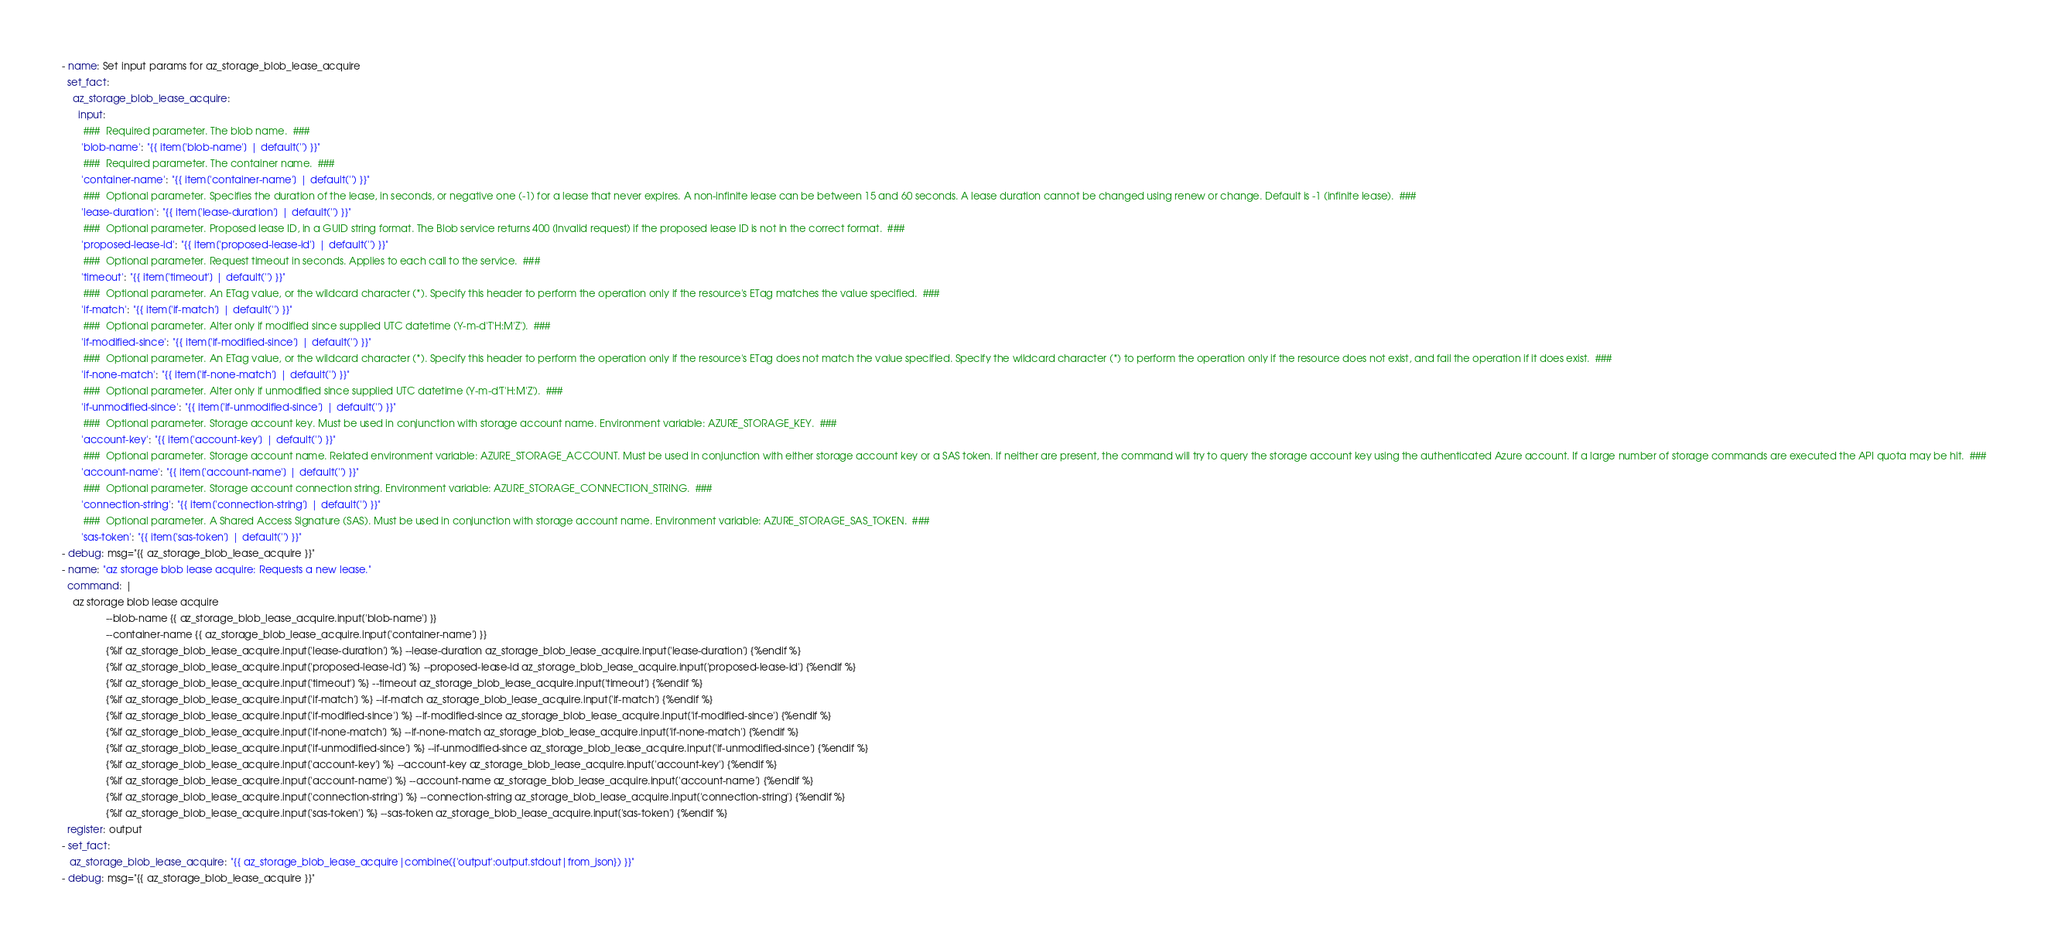Convert code to text. <code><loc_0><loc_0><loc_500><loc_500><_YAML_>

 - name: Set input params for az_storage_blob_lease_acquire
   set_fact: 
     az_storage_blob_lease_acquire:
       input: 
         ###  Required parameter. The blob name.  ### 
        'blob-name': "{{ item['blob-name'] | default('') }}" 
         ###  Required parameter. The container name.  ### 
        'container-name': "{{ item['container-name'] | default('') }}" 
         ###  Optional parameter. Specifies the duration of the lease, in seconds, or negative one (-1) for a lease that never expires. A non-infinite lease can be between 15 and 60 seconds. A lease duration cannot be changed using renew or change. Default is -1 (infinite lease).  ### 
        'lease-duration': "{{ item['lease-duration'] | default('') }}" 
         ###  Optional parameter. Proposed lease ID, in a GUID string format. The Blob service returns 400 (Invalid request) if the proposed lease ID is not in the correct format.  ### 
        'proposed-lease-id': "{{ item['proposed-lease-id'] | default('') }}" 
         ###  Optional parameter. Request timeout in seconds. Applies to each call to the service.  ### 
        'timeout': "{{ item['timeout'] | default('') }}" 
         ###  Optional parameter. An ETag value, or the wildcard character (*). Specify this header to perform the operation only if the resource's ETag matches the value specified.  ### 
        'if-match': "{{ item['if-match'] | default('') }}" 
         ###  Optional parameter. Alter only if modified since supplied UTC datetime (Y-m-d'T'H:M'Z').  ### 
        'if-modified-since': "{{ item['if-modified-since'] | default('') }}" 
         ###  Optional parameter. An ETag value, or the wildcard character (*). Specify this header to perform the operation only if the resource's ETag does not match the value specified. Specify the wildcard character (*) to perform the operation only if the resource does not exist, and fail the operation if it does exist.  ### 
        'if-none-match': "{{ item['if-none-match'] | default('') }}" 
         ###  Optional parameter. Alter only if unmodified since supplied UTC datetime (Y-m-d'T'H:M'Z').  ### 
        'if-unmodified-since': "{{ item['if-unmodified-since'] | default('') }}" 
         ###  Optional parameter. Storage account key. Must be used in conjunction with storage account name. Environment variable: AZURE_STORAGE_KEY.  ### 
        'account-key': "{{ item['account-key'] | default('') }}" 
         ###  Optional parameter. Storage account name. Related environment variable: AZURE_STORAGE_ACCOUNT. Must be used in conjunction with either storage account key or a SAS token. If neither are present, the command will try to query the storage account key using the authenticated Azure account. If a large number of storage commands are executed the API quota may be hit.  ### 
        'account-name': "{{ item['account-name'] | default('') }}" 
         ###  Optional parameter. Storage account connection string. Environment variable: AZURE_STORAGE_CONNECTION_STRING.  ### 
        'connection-string': "{{ item['connection-string'] | default('') }}" 
         ###  Optional parameter. A Shared Access Signature (SAS). Must be used in conjunction with storage account name. Environment variable: AZURE_STORAGE_SAS_TOKEN.  ### 
        'sas-token': "{{ item['sas-token'] | default('') }}" 
 - debug: msg="{{ az_storage_blob_lease_acquire }}"          
 - name: "az storage blob lease acquire: Requests a new lease." 
   command: |                                      
     az storage blob lease acquire                            
                 --blob-name {{ az_storage_blob_lease_acquire.input['blob-name'] }} 
                 --container-name {{ az_storage_blob_lease_acquire.input['container-name'] }} 
                 {%if az_storage_blob_lease_acquire.input['lease-duration'] %} --lease-duration az_storage_blob_lease_acquire.input['lease-duration'] {%endif %} 
                 {%if az_storage_blob_lease_acquire.input['proposed-lease-id'] %} --proposed-lease-id az_storage_blob_lease_acquire.input['proposed-lease-id'] {%endif %} 
                 {%if az_storage_blob_lease_acquire.input['timeout'] %} --timeout az_storage_blob_lease_acquire.input['timeout'] {%endif %} 
                 {%if az_storage_blob_lease_acquire.input['if-match'] %} --if-match az_storage_blob_lease_acquire.input['if-match'] {%endif %} 
                 {%if az_storage_blob_lease_acquire.input['if-modified-since'] %} --if-modified-since az_storage_blob_lease_acquire.input['if-modified-since'] {%endif %} 
                 {%if az_storage_blob_lease_acquire.input['if-none-match'] %} --if-none-match az_storage_blob_lease_acquire.input['if-none-match'] {%endif %} 
                 {%if az_storage_blob_lease_acquire.input['if-unmodified-since'] %} --if-unmodified-since az_storage_blob_lease_acquire.input['if-unmodified-since'] {%endif %} 
                 {%if az_storage_blob_lease_acquire.input['account-key'] %} --account-key az_storage_blob_lease_acquire.input['account-key'] {%endif %} 
                 {%if az_storage_blob_lease_acquire.input['account-name'] %} --account-name az_storage_blob_lease_acquire.input['account-name'] {%endif %} 
                 {%if az_storage_blob_lease_acquire.input['connection-string'] %} --connection-string az_storage_blob_lease_acquire.input['connection-string'] {%endif %} 
                 {%if az_storage_blob_lease_acquire.input['sas-token'] %} --sas-token az_storage_blob_lease_acquire.input['sas-token'] {%endif %} 
   register: output  
 - set_fact: 
    az_storage_blob_lease_acquire: "{{ az_storage_blob_lease_acquire|combine({'output':output.stdout|from_json}) }}"  
 - debug: msg="{{ az_storage_blob_lease_acquire }}" 
</code> 